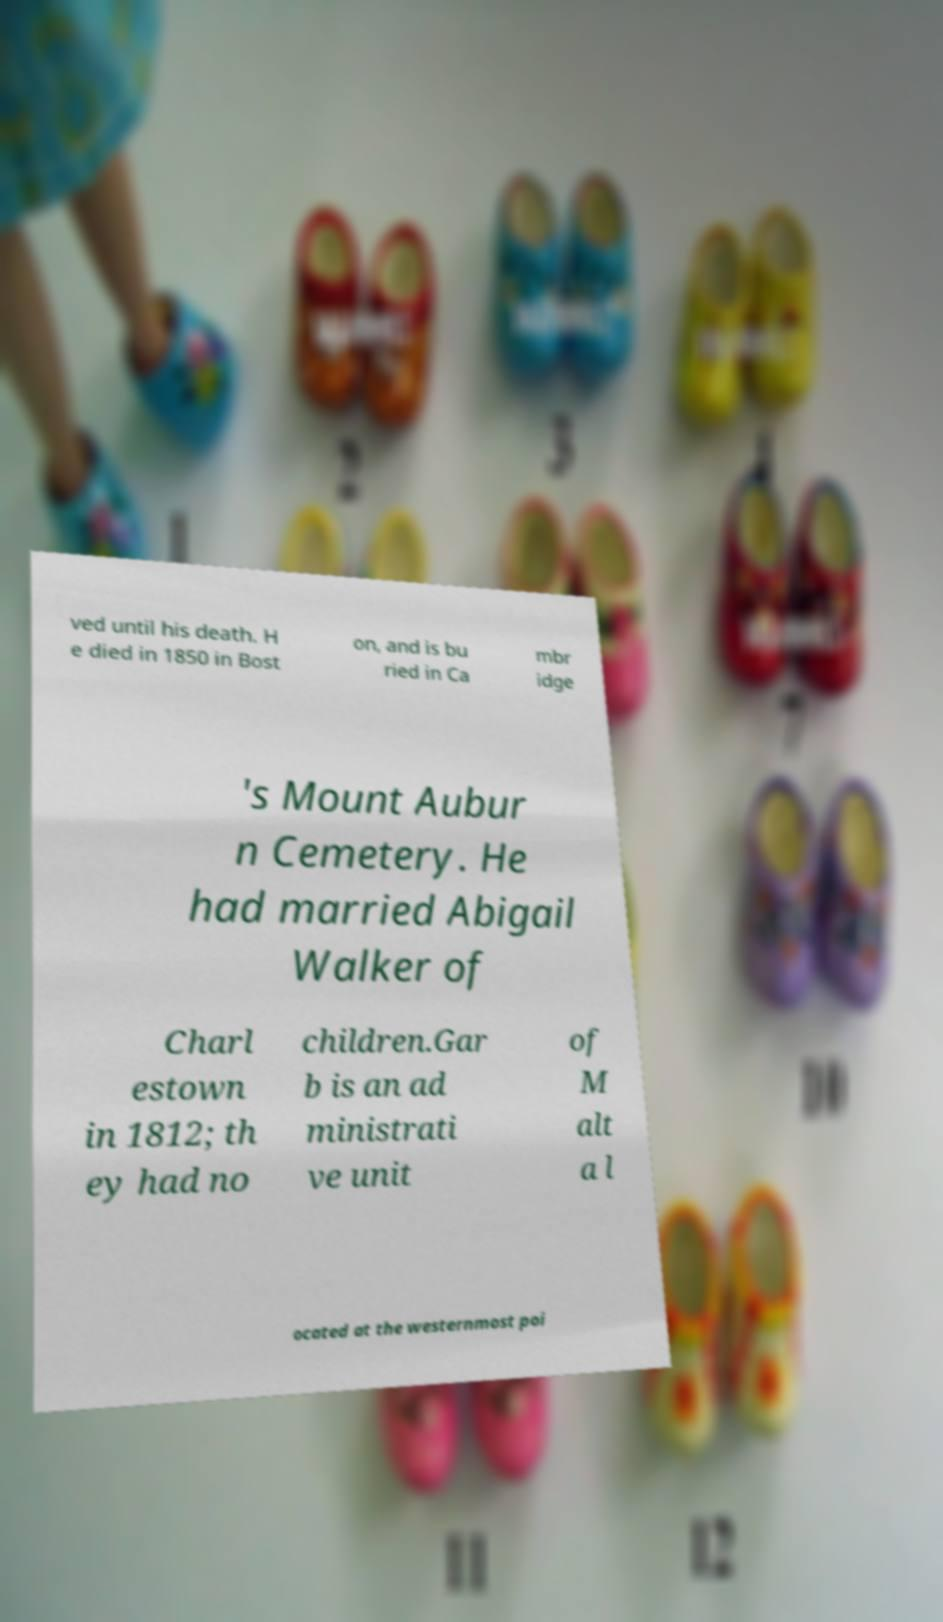There's text embedded in this image that I need extracted. Can you transcribe it verbatim? ved until his death. H e died in 1850 in Bost on, and is bu ried in Ca mbr idge 's Mount Aubur n Cemetery. He had married Abigail Walker of Charl estown in 1812; th ey had no children.Gar b is an ad ministrati ve unit of M alt a l ocated at the westernmost poi 